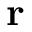<formula> <loc_0><loc_0><loc_500><loc_500>{ r }</formula> 